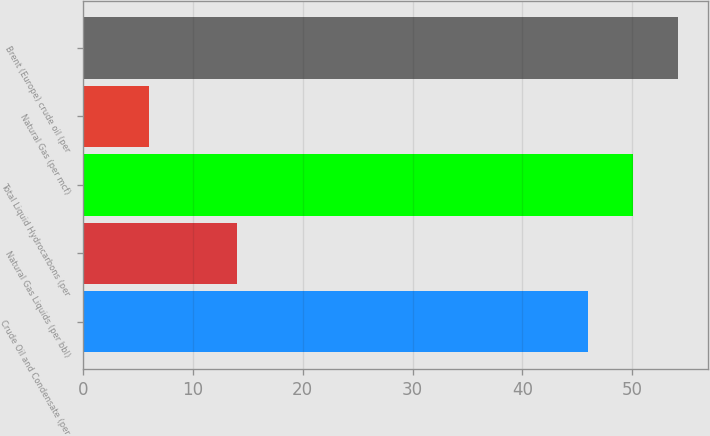<chart> <loc_0><loc_0><loc_500><loc_500><bar_chart><fcel>Crude Oil and Condensate (per<fcel>Natural Gas Liquids (per bbl)<fcel>Total Liquid Hydrocarbons (per<fcel>Natural Gas (per mcf)<fcel>Brent (Europe) crude oil (per<nl><fcel>46<fcel>14<fcel>50.1<fcel>6<fcel>54.2<nl></chart> 